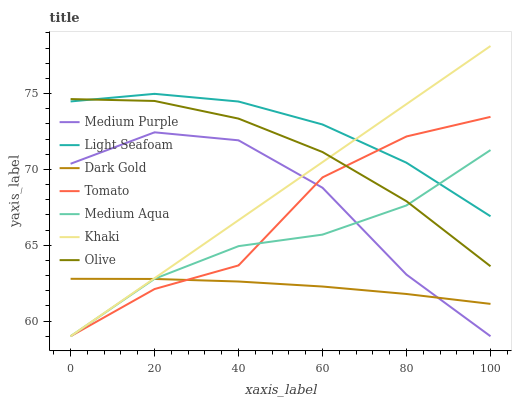Does Dark Gold have the minimum area under the curve?
Answer yes or no. Yes. Does Light Seafoam have the maximum area under the curve?
Answer yes or no. Yes. Does Khaki have the minimum area under the curve?
Answer yes or no. No. Does Khaki have the maximum area under the curve?
Answer yes or no. No. Is Khaki the smoothest?
Answer yes or no. Yes. Is Tomato the roughest?
Answer yes or no. Yes. Is Dark Gold the smoothest?
Answer yes or no. No. Is Dark Gold the roughest?
Answer yes or no. No. Does Dark Gold have the lowest value?
Answer yes or no. No. Does Khaki have the highest value?
Answer yes or no. Yes. Does Dark Gold have the highest value?
Answer yes or no. No. Is Medium Purple less than Olive?
Answer yes or no. Yes. Is Light Seafoam greater than Medium Purple?
Answer yes or no. Yes. Does Tomato intersect Medium Aqua?
Answer yes or no. Yes. Is Tomato less than Medium Aqua?
Answer yes or no. No. Is Tomato greater than Medium Aqua?
Answer yes or no. No. Does Medium Purple intersect Olive?
Answer yes or no. No. 